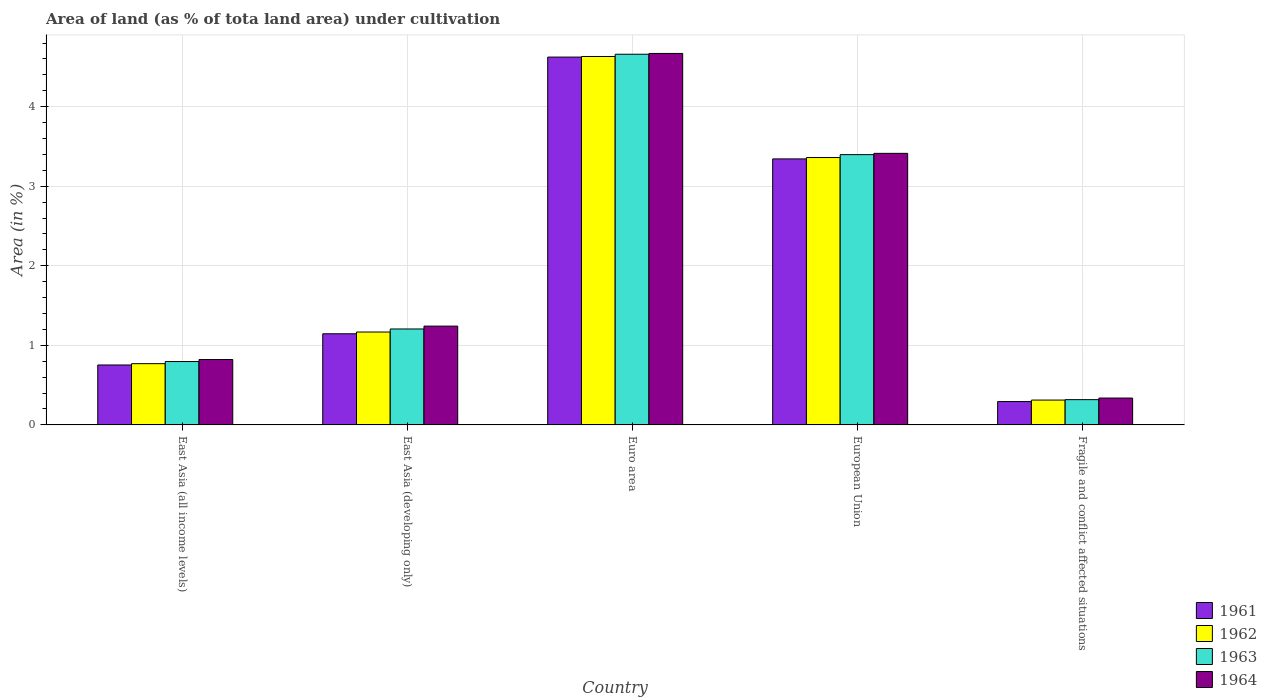How many groups of bars are there?
Your answer should be compact. 5. Are the number of bars per tick equal to the number of legend labels?
Your answer should be very brief. Yes. Are the number of bars on each tick of the X-axis equal?
Ensure brevity in your answer.  Yes. How many bars are there on the 2nd tick from the right?
Your answer should be compact. 4. What is the label of the 2nd group of bars from the left?
Your answer should be very brief. East Asia (developing only). What is the percentage of land under cultivation in 1961 in Euro area?
Provide a succinct answer. 4.62. Across all countries, what is the maximum percentage of land under cultivation in 1963?
Your answer should be compact. 4.66. Across all countries, what is the minimum percentage of land under cultivation in 1962?
Ensure brevity in your answer.  0.31. In which country was the percentage of land under cultivation in 1964 maximum?
Your answer should be very brief. Euro area. In which country was the percentage of land under cultivation in 1961 minimum?
Provide a succinct answer. Fragile and conflict affected situations. What is the total percentage of land under cultivation in 1962 in the graph?
Your answer should be compact. 10.24. What is the difference between the percentage of land under cultivation in 1961 in East Asia (developing only) and that in Fragile and conflict affected situations?
Your answer should be very brief. 0.85. What is the difference between the percentage of land under cultivation in 1963 in European Union and the percentage of land under cultivation in 1964 in East Asia (developing only)?
Give a very brief answer. 2.16. What is the average percentage of land under cultivation in 1962 per country?
Keep it short and to the point. 2.05. What is the difference between the percentage of land under cultivation of/in 1961 and percentage of land under cultivation of/in 1963 in Fragile and conflict affected situations?
Make the answer very short. -0.02. In how many countries, is the percentage of land under cultivation in 1964 greater than 1.2 %?
Your response must be concise. 3. What is the ratio of the percentage of land under cultivation in 1962 in East Asia (all income levels) to that in Fragile and conflict affected situations?
Your response must be concise. 2.47. Is the percentage of land under cultivation in 1964 in East Asia (all income levels) less than that in Fragile and conflict affected situations?
Your answer should be very brief. No. Is the difference between the percentage of land under cultivation in 1961 in European Union and Fragile and conflict affected situations greater than the difference between the percentage of land under cultivation in 1963 in European Union and Fragile and conflict affected situations?
Your answer should be very brief. No. What is the difference between the highest and the second highest percentage of land under cultivation in 1961?
Your response must be concise. -2.2. What is the difference between the highest and the lowest percentage of land under cultivation in 1963?
Make the answer very short. 4.34. What does the 2nd bar from the left in European Union represents?
Offer a terse response. 1962. What does the 2nd bar from the right in East Asia (developing only) represents?
Your answer should be very brief. 1963. How many bars are there?
Offer a very short reply. 20. Are all the bars in the graph horizontal?
Keep it short and to the point. No. What is the difference between two consecutive major ticks on the Y-axis?
Offer a terse response. 1. Are the values on the major ticks of Y-axis written in scientific E-notation?
Offer a terse response. No. Does the graph contain any zero values?
Your answer should be compact. No. Does the graph contain grids?
Keep it short and to the point. Yes. Where does the legend appear in the graph?
Provide a short and direct response. Bottom right. What is the title of the graph?
Provide a short and direct response. Area of land (as % of tota land area) under cultivation. Does "2014" appear as one of the legend labels in the graph?
Provide a short and direct response. No. What is the label or title of the X-axis?
Keep it short and to the point. Country. What is the label or title of the Y-axis?
Your answer should be very brief. Area (in %). What is the Area (in %) in 1961 in East Asia (all income levels)?
Offer a very short reply. 0.75. What is the Area (in %) in 1962 in East Asia (all income levels)?
Your response must be concise. 0.77. What is the Area (in %) in 1963 in East Asia (all income levels)?
Keep it short and to the point. 0.8. What is the Area (in %) of 1964 in East Asia (all income levels)?
Ensure brevity in your answer.  0.82. What is the Area (in %) of 1961 in East Asia (developing only)?
Make the answer very short. 1.15. What is the Area (in %) in 1962 in East Asia (developing only)?
Ensure brevity in your answer.  1.17. What is the Area (in %) of 1963 in East Asia (developing only)?
Your response must be concise. 1.21. What is the Area (in %) of 1964 in East Asia (developing only)?
Offer a very short reply. 1.24. What is the Area (in %) in 1961 in Euro area?
Your response must be concise. 4.62. What is the Area (in %) of 1962 in Euro area?
Provide a short and direct response. 4.63. What is the Area (in %) in 1963 in Euro area?
Your response must be concise. 4.66. What is the Area (in %) of 1964 in Euro area?
Offer a very short reply. 4.67. What is the Area (in %) of 1961 in European Union?
Ensure brevity in your answer.  3.34. What is the Area (in %) of 1962 in European Union?
Keep it short and to the point. 3.36. What is the Area (in %) in 1963 in European Union?
Ensure brevity in your answer.  3.4. What is the Area (in %) in 1964 in European Union?
Make the answer very short. 3.41. What is the Area (in %) of 1961 in Fragile and conflict affected situations?
Ensure brevity in your answer.  0.29. What is the Area (in %) in 1962 in Fragile and conflict affected situations?
Keep it short and to the point. 0.31. What is the Area (in %) in 1963 in Fragile and conflict affected situations?
Ensure brevity in your answer.  0.32. What is the Area (in %) in 1964 in Fragile and conflict affected situations?
Ensure brevity in your answer.  0.34. Across all countries, what is the maximum Area (in %) in 1961?
Make the answer very short. 4.62. Across all countries, what is the maximum Area (in %) of 1962?
Your response must be concise. 4.63. Across all countries, what is the maximum Area (in %) of 1963?
Ensure brevity in your answer.  4.66. Across all countries, what is the maximum Area (in %) of 1964?
Offer a terse response. 4.67. Across all countries, what is the minimum Area (in %) in 1961?
Give a very brief answer. 0.29. Across all countries, what is the minimum Area (in %) in 1962?
Your answer should be very brief. 0.31. Across all countries, what is the minimum Area (in %) in 1963?
Provide a succinct answer. 0.32. Across all countries, what is the minimum Area (in %) of 1964?
Your answer should be compact. 0.34. What is the total Area (in %) in 1961 in the graph?
Your response must be concise. 10.16. What is the total Area (in %) of 1962 in the graph?
Provide a succinct answer. 10.24. What is the total Area (in %) in 1963 in the graph?
Provide a succinct answer. 10.38. What is the total Area (in %) in 1964 in the graph?
Give a very brief answer. 10.48. What is the difference between the Area (in %) of 1961 in East Asia (all income levels) and that in East Asia (developing only)?
Your answer should be very brief. -0.39. What is the difference between the Area (in %) of 1962 in East Asia (all income levels) and that in East Asia (developing only)?
Your answer should be compact. -0.4. What is the difference between the Area (in %) of 1963 in East Asia (all income levels) and that in East Asia (developing only)?
Your answer should be very brief. -0.41. What is the difference between the Area (in %) of 1964 in East Asia (all income levels) and that in East Asia (developing only)?
Your answer should be compact. -0.42. What is the difference between the Area (in %) of 1961 in East Asia (all income levels) and that in Euro area?
Offer a terse response. -3.87. What is the difference between the Area (in %) of 1962 in East Asia (all income levels) and that in Euro area?
Provide a short and direct response. -3.86. What is the difference between the Area (in %) in 1963 in East Asia (all income levels) and that in Euro area?
Keep it short and to the point. -3.86. What is the difference between the Area (in %) in 1964 in East Asia (all income levels) and that in Euro area?
Make the answer very short. -3.85. What is the difference between the Area (in %) in 1961 in East Asia (all income levels) and that in European Union?
Give a very brief answer. -2.59. What is the difference between the Area (in %) of 1962 in East Asia (all income levels) and that in European Union?
Your response must be concise. -2.59. What is the difference between the Area (in %) of 1963 in East Asia (all income levels) and that in European Union?
Provide a succinct answer. -2.6. What is the difference between the Area (in %) in 1964 in East Asia (all income levels) and that in European Union?
Give a very brief answer. -2.59. What is the difference between the Area (in %) in 1961 in East Asia (all income levels) and that in Fragile and conflict affected situations?
Offer a very short reply. 0.46. What is the difference between the Area (in %) in 1962 in East Asia (all income levels) and that in Fragile and conflict affected situations?
Your answer should be compact. 0.46. What is the difference between the Area (in %) of 1963 in East Asia (all income levels) and that in Fragile and conflict affected situations?
Make the answer very short. 0.48. What is the difference between the Area (in %) of 1964 in East Asia (all income levels) and that in Fragile and conflict affected situations?
Offer a very short reply. 0.48. What is the difference between the Area (in %) in 1961 in East Asia (developing only) and that in Euro area?
Your response must be concise. -3.48. What is the difference between the Area (in %) of 1962 in East Asia (developing only) and that in Euro area?
Ensure brevity in your answer.  -3.46. What is the difference between the Area (in %) of 1963 in East Asia (developing only) and that in Euro area?
Keep it short and to the point. -3.45. What is the difference between the Area (in %) in 1964 in East Asia (developing only) and that in Euro area?
Offer a very short reply. -3.43. What is the difference between the Area (in %) in 1961 in East Asia (developing only) and that in European Union?
Ensure brevity in your answer.  -2.2. What is the difference between the Area (in %) of 1962 in East Asia (developing only) and that in European Union?
Ensure brevity in your answer.  -2.19. What is the difference between the Area (in %) in 1963 in East Asia (developing only) and that in European Union?
Your answer should be very brief. -2.19. What is the difference between the Area (in %) in 1964 in East Asia (developing only) and that in European Union?
Your answer should be compact. -2.17. What is the difference between the Area (in %) of 1961 in East Asia (developing only) and that in Fragile and conflict affected situations?
Your response must be concise. 0.85. What is the difference between the Area (in %) of 1962 in East Asia (developing only) and that in Fragile and conflict affected situations?
Your response must be concise. 0.86. What is the difference between the Area (in %) in 1963 in East Asia (developing only) and that in Fragile and conflict affected situations?
Keep it short and to the point. 0.89. What is the difference between the Area (in %) in 1964 in East Asia (developing only) and that in Fragile and conflict affected situations?
Provide a succinct answer. 0.9. What is the difference between the Area (in %) in 1961 in Euro area and that in European Union?
Your answer should be compact. 1.28. What is the difference between the Area (in %) in 1962 in Euro area and that in European Union?
Make the answer very short. 1.27. What is the difference between the Area (in %) of 1963 in Euro area and that in European Union?
Offer a terse response. 1.26. What is the difference between the Area (in %) in 1964 in Euro area and that in European Union?
Ensure brevity in your answer.  1.26. What is the difference between the Area (in %) of 1961 in Euro area and that in Fragile and conflict affected situations?
Make the answer very short. 4.33. What is the difference between the Area (in %) of 1962 in Euro area and that in Fragile and conflict affected situations?
Make the answer very short. 4.32. What is the difference between the Area (in %) in 1963 in Euro area and that in Fragile and conflict affected situations?
Ensure brevity in your answer.  4.34. What is the difference between the Area (in %) in 1964 in Euro area and that in Fragile and conflict affected situations?
Give a very brief answer. 4.33. What is the difference between the Area (in %) in 1961 in European Union and that in Fragile and conflict affected situations?
Offer a terse response. 3.05. What is the difference between the Area (in %) in 1962 in European Union and that in Fragile and conflict affected situations?
Ensure brevity in your answer.  3.05. What is the difference between the Area (in %) in 1963 in European Union and that in Fragile and conflict affected situations?
Make the answer very short. 3.08. What is the difference between the Area (in %) of 1964 in European Union and that in Fragile and conflict affected situations?
Your answer should be compact. 3.08. What is the difference between the Area (in %) of 1961 in East Asia (all income levels) and the Area (in %) of 1962 in East Asia (developing only)?
Your answer should be compact. -0.41. What is the difference between the Area (in %) of 1961 in East Asia (all income levels) and the Area (in %) of 1963 in East Asia (developing only)?
Offer a terse response. -0.45. What is the difference between the Area (in %) in 1961 in East Asia (all income levels) and the Area (in %) in 1964 in East Asia (developing only)?
Provide a short and direct response. -0.49. What is the difference between the Area (in %) of 1962 in East Asia (all income levels) and the Area (in %) of 1963 in East Asia (developing only)?
Keep it short and to the point. -0.44. What is the difference between the Area (in %) of 1962 in East Asia (all income levels) and the Area (in %) of 1964 in East Asia (developing only)?
Keep it short and to the point. -0.47. What is the difference between the Area (in %) in 1963 in East Asia (all income levels) and the Area (in %) in 1964 in East Asia (developing only)?
Your response must be concise. -0.45. What is the difference between the Area (in %) of 1961 in East Asia (all income levels) and the Area (in %) of 1962 in Euro area?
Ensure brevity in your answer.  -3.88. What is the difference between the Area (in %) in 1961 in East Asia (all income levels) and the Area (in %) in 1963 in Euro area?
Provide a succinct answer. -3.91. What is the difference between the Area (in %) of 1961 in East Asia (all income levels) and the Area (in %) of 1964 in Euro area?
Provide a succinct answer. -3.92. What is the difference between the Area (in %) in 1962 in East Asia (all income levels) and the Area (in %) in 1963 in Euro area?
Ensure brevity in your answer.  -3.89. What is the difference between the Area (in %) in 1962 in East Asia (all income levels) and the Area (in %) in 1964 in Euro area?
Offer a very short reply. -3.9. What is the difference between the Area (in %) of 1963 in East Asia (all income levels) and the Area (in %) of 1964 in Euro area?
Provide a short and direct response. -3.87. What is the difference between the Area (in %) of 1961 in East Asia (all income levels) and the Area (in %) of 1962 in European Union?
Make the answer very short. -2.61. What is the difference between the Area (in %) in 1961 in East Asia (all income levels) and the Area (in %) in 1963 in European Union?
Your answer should be very brief. -2.64. What is the difference between the Area (in %) in 1961 in East Asia (all income levels) and the Area (in %) in 1964 in European Union?
Ensure brevity in your answer.  -2.66. What is the difference between the Area (in %) of 1962 in East Asia (all income levels) and the Area (in %) of 1963 in European Union?
Keep it short and to the point. -2.63. What is the difference between the Area (in %) in 1962 in East Asia (all income levels) and the Area (in %) in 1964 in European Union?
Keep it short and to the point. -2.64. What is the difference between the Area (in %) in 1963 in East Asia (all income levels) and the Area (in %) in 1964 in European Union?
Offer a terse response. -2.62. What is the difference between the Area (in %) of 1961 in East Asia (all income levels) and the Area (in %) of 1962 in Fragile and conflict affected situations?
Your answer should be very brief. 0.44. What is the difference between the Area (in %) in 1961 in East Asia (all income levels) and the Area (in %) in 1963 in Fragile and conflict affected situations?
Provide a succinct answer. 0.44. What is the difference between the Area (in %) of 1961 in East Asia (all income levels) and the Area (in %) of 1964 in Fragile and conflict affected situations?
Your answer should be compact. 0.42. What is the difference between the Area (in %) of 1962 in East Asia (all income levels) and the Area (in %) of 1963 in Fragile and conflict affected situations?
Offer a very short reply. 0.45. What is the difference between the Area (in %) of 1962 in East Asia (all income levels) and the Area (in %) of 1964 in Fragile and conflict affected situations?
Your answer should be compact. 0.43. What is the difference between the Area (in %) of 1963 in East Asia (all income levels) and the Area (in %) of 1964 in Fragile and conflict affected situations?
Provide a succinct answer. 0.46. What is the difference between the Area (in %) of 1961 in East Asia (developing only) and the Area (in %) of 1962 in Euro area?
Offer a terse response. -3.49. What is the difference between the Area (in %) in 1961 in East Asia (developing only) and the Area (in %) in 1963 in Euro area?
Provide a succinct answer. -3.51. What is the difference between the Area (in %) in 1961 in East Asia (developing only) and the Area (in %) in 1964 in Euro area?
Provide a succinct answer. -3.52. What is the difference between the Area (in %) in 1962 in East Asia (developing only) and the Area (in %) in 1963 in Euro area?
Your answer should be compact. -3.49. What is the difference between the Area (in %) in 1962 in East Asia (developing only) and the Area (in %) in 1964 in Euro area?
Keep it short and to the point. -3.5. What is the difference between the Area (in %) of 1963 in East Asia (developing only) and the Area (in %) of 1964 in Euro area?
Provide a short and direct response. -3.46. What is the difference between the Area (in %) in 1961 in East Asia (developing only) and the Area (in %) in 1962 in European Union?
Keep it short and to the point. -2.22. What is the difference between the Area (in %) of 1961 in East Asia (developing only) and the Area (in %) of 1963 in European Union?
Provide a short and direct response. -2.25. What is the difference between the Area (in %) in 1961 in East Asia (developing only) and the Area (in %) in 1964 in European Union?
Your response must be concise. -2.27. What is the difference between the Area (in %) in 1962 in East Asia (developing only) and the Area (in %) in 1963 in European Union?
Provide a succinct answer. -2.23. What is the difference between the Area (in %) in 1962 in East Asia (developing only) and the Area (in %) in 1964 in European Union?
Offer a very short reply. -2.25. What is the difference between the Area (in %) in 1963 in East Asia (developing only) and the Area (in %) in 1964 in European Union?
Give a very brief answer. -2.21. What is the difference between the Area (in %) of 1961 in East Asia (developing only) and the Area (in %) of 1962 in Fragile and conflict affected situations?
Offer a very short reply. 0.83. What is the difference between the Area (in %) of 1961 in East Asia (developing only) and the Area (in %) of 1963 in Fragile and conflict affected situations?
Your answer should be compact. 0.83. What is the difference between the Area (in %) in 1961 in East Asia (developing only) and the Area (in %) in 1964 in Fragile and conflict affected situations?
Your answer should be compact. 0.81. What is the difference between the Area (in %) in 1962 in East Asia (developing only) and the Area (in %) in 1963 in Fragile and conflict affected situations?
Ensure brevity in your answer.  0.85. What is the difference between the Area (in %) in 1962 in East Asia (developing only) and the Area (in %) in 1964 in Fragile and conflict affected situations?
Give a very brief answer. 0.83. What is the difference between the Area (in %) in 1963 in East Asia (developing only) and the Area (in %) in 1964 in Fragile and conflict affected situations?
Keep it short and to the point. 0.87. What is the difference between the Area (in %) in 1961 in Euro area and the Area (in %) in 1962 in European Union?
Your answer should be very brief. 1.26. What is the difference between the Area (in %) in 1961 in Euro area and the Area (in %) in 1963 in European Union?
Offer a terse response. 1.23. What is the difference between the Area (in %) of 1961 in Euro area and the Area (in %) of 1964 in European Union?
Keep it short and to the point. 1.21. What is the difference between the Area (in %) of 1962 in Euro area and the Area (in %) of 1963 in European Union?
Offer a very short reply. 1.23. What is the difference between the Area (in %) in 1962 in Euro area and the Area (in %) in 1964 in European Union?
Your response must be concise. 1.22. What is the difference between the Area (in %) in 1963 in Euro area and the Area (in %) in 1964 in European Union?
Offer a very short reply. 1.25. What is the difference between the Area (in %) of 1961 in Euro area and the Area (in %) of 1962 in Fragile and conflict affected situations?
Offer a terse response. 4.31. What is the difference between the Area (in %) of 1961 in Euro area and the Area (in %) of 1963 in Fragile and conflict affected situations?
Offer a very short reply. 4.31. What is the difference between the Area (in %) in 1961 in Euro area and the Area (in %) in 1964 in Fragile and conflict affected situations?
Make the answer very short. 4.29. What is the difference between the Area (in %) in 1962 in Euro area and the Area (in %) in 1963 in Fragile and conflict affected situations?
Offer a terse response. 4.31. What is the difference between the Area (in %) of 1962 in Euro area and the Area (in %) of 1964 in Fragile and conflict affected situations?
Give a very brief answer. 4.29. What is the difference between the Area (in %) of 1963 in Euro area and the Area (in %) of 1964 in Fragile and conflict affected situations?
Ensure brevity in your answer.  4.32. What is the difference between the Area (in %) of 1961 in European Union and the Area (in %) of 1962 in Fragile and conflict affected situations?
Keep it short and to the point. 3.03. What is the difference between the Area (in %) of 1961 in European Union and the Area (in %) of 1963 in Fragile and conflict affected situations?
Make the answer very short. 3.03. What is the difference between the Area (in %) in 1961 in European Union and the Area (in %) in 1964 in Fragile and conflict affected situations?
Make the answer very short. 3.01. What is the difference between the Area (in %) of 1962 in European Union and the Area (in %) of 1963 in Fragile and conflict affected situations?
Keep it short and to the point. 3.04. What is the difference between the Area (in %) of 1962 in European Union and the Area (in %) of 1964 in Fragile and conflict affected situations?
Offer a terse response. 3.02. What is the difference between the Area (in %) of 1963 in European Union and the Area (in %) of 1964 in Fragile and conflict affected situations?
Provide a succinct answer. 3.06. What is the average Area (in %) of 1961 per country?
Your response must be concise. 2.03. What is the average Area (in %) of 1962 per country?
Offer a terse response. 2.05. What is the average Area (in %) in 1963 per country?
Your answer should be compact. 2.08. What is the average Area (in %) of 1964 per country?
Your response must be concise. 2.1. What is the difference between the Area (in %) in 1961 and Area (in %) in 1962 in East Asia (all income levels)?
Offer a terse response. -0.02. What is the difference between the Area (in %) of 1961 and Area (in %) of 1963 in East Asia (all income levels)?
Offer a very short reply. -0.04. What is the difference between the Area (in %) in 1961 and Area (in %) in 1964 in East Asia (all income levels)?
Make the answer very short. -0.07. What is the difference between the Area (in %) in 1962 and Area (in %) in 1963 in East Asia (all income levels)?
Your answer should be compact. -0.03. What is the difference between the Area (in %) of 1962 and Area (in %) of 1964 in East Asia (all income levels)?
Keep it short and to the point. -0.05. What is the difference between the Area (in %) of 1963 and Area (in %) of 1964 in East Asia (all income levels)?
Offer a terse response. -0.03. What is the difference between the Area (in %) of 1961 and Area (in %) of 1962 in East Asia (developing only)?
Keep it short and to the point. -0.02. What is the difference between the Area (in %) of 1961 and Area (in %) of 1963 in East Asia (developing only)?
Keep it short and to the point. -0.06. What is the difference between the Area (in %) of 1961 and Area (in %) of 1964 in East Asia (developing only)?
Your answer should be very brief. -0.1. What is the difference between the Area (in %) in 1962 and Area (in %) in 1963 in East Asia (developing only)?
Your response must be concise. -0.04. What is the difference between the Area (in %) of 1962 and Area (in %) of 1964 in East Asia (developing only)?
Provide a succinct answer. -0.07. What is the difference between the Area (in %) in 1963 and Area (in %) in 1964 in East Asia (developing only)?
Offer a very short reply. -0.04. What is the difference between the Area (in %) of 1961 and Area (in %) of 1962 in Euro area?
Give a very brief answer. -0.01. What is the difference between the Area (in %) of 1961 and Area (in %) of 1963 in Euro area?
Offer a very short reply. -0.04. What is the difference between the Area (in %) in 1961 and Area (in %) in 1964 in Euro area?
Offer a very short reply. -0.05. What is the difference between the Area (in %) of 1962 and Area (in %) of 1963 in Euro area?
Offer a very short reply. -0.03. What is the difference between the Area (in %) in 1962 and Area (in %) in 1964 in Euro area?
Your response must be concise. -0.04. What is the difference between the Area (in %) of 1963 and Area (in %) of 1964 in Euro area?
Give a very brief answer. -0.01. What is the difference between the Area (in %) of 1961 and Area (in %) of 1962 in European Union?
Your response must be concise. -0.02. What is the difference between the Area (in %) in 1961 and Area (in %) in 1963 in European Union?
Keep it short and to the point. -0.05. What is the difference between the Area (in %) of 1961 and Area (in %) of 1964 in European Union?
Your answer should be very brief. -0.07. What is the difference between the Area (in %) of 1962 and Area (in %) of 1963 in European Union?
Your answer should be compact. -0.04. What is the difference between the Area (in %) in 1962 and Area (in %) in 1964 in European Union?
Your answer should be compact. -0.05. What is the difference between the Area (in %) in 1963 and Area (in %) in 1964 in European Union?
Make the answer very short. -0.02. What is the difference between the Area (in %) in 1961 and Area (in %) in 1962 in Fragile and conflict affected situations?
Offer a terse response. -0.02. What is the difference between the Area (in %) in 1961 and Area (in %) in 1963 in Fragile and conflict affected situations?
Your response must be concise. -0.02. What is the difference between the Area (in %) of 1961 and Area (in %) of 1964 in Fragile and conflict affected situations?
Provide a succinct answer. -0.04. What is the difference between the Area (in %) in 1962 and Area (in %) in 1963 in Fragile and conflict affected situations?
Offer a very short reply. -0.01. What is the difference between the Area (in %) in 1962 and Area (in %) in 1964 in Fragile and conflict affected situations?
Offer a very short reply. -0.03. What is the difference between the Area (in %) in 1963 and Area (in %) in 1964 in Fragile and conflict affected situations?
Keep it short and to the point. -0.02. What is the ratio of the Area (in %) of 1961 in East Asia (all income levels) to that in East Asia (developing only)?
Offer a terse response. 0.66. What is the ratio of the Area (in %) of 1962 in East Asia (all income levels) to that in East Asia (developing only)?
Provide a succinct answer. 0.66. What is the ratio of the Area (in %) in 1963 in East Asia (all income levels) to that in East Asia (developing only)?
Provide a short and direct response. 0.66. What is the ratio of the Area (in %) of 1964 in East Asia (all income levels) to that in East Asia (developing only)?
Ensure brevity in your answer.  0.66. What is the ratio of the Area (in %) in 1961 in East Asia (all income levels) to that in Euro area?
Offer a terse response. 0.16. What is the ratio of the Area (in %) in 1962 in East Asia (all income levels) to that in Euro area?
Provide a short and direct response. 0.17. What is the ratio of the Area (in %) in 1963 in East Asia (all income levels) to that in Euro area?
Make the answer very short. 0.17. What is the ratio of the Area (in %) in 1964 in East Asia (all income levels) to that in Euro area?
Keep it short and to the point. 0.18. What is the ratio of the Area (in %) in 1961 in East Asia (all income levels) to that in European Union?
Ensure brevity in your answer.  0.23. What is the ratio of the Area (in %) in 1962 in East Asia (all income levels) to that in European Union?
Offer a terse response. 0.23. What is the ratio of the Area (in %) of 1963 in East Asia (all income levels) to that in European Union?
Give a very brief answer. 0.23. What is the ratio of the Area (in %) of 1964 in East Asia (all income levels) to that in European Union?
Keep it short and to the point. 0.24. What is the ratio of the Area (in %) in 1961 in East Asia (all income levels) to that in Fragile and conflict affected situations?
Offer a very short reply. 2.57. What is the ratio of the Area (in %) of 1962 in East Asia (all income levels) to that in Fragile and conflict affected situations?
Ensure brevity in your answer.  2.47. What is the ratio of the Area (in %) in 1963 in East Asia (all income levels) to that in Fragile and conflict affected situations?
Offer a very short reply. 2.51. What is the ratio of the Area (in %) in 1964 in East Asia (all income levels) to that in Fragile and conflict affected situations?
Offer a terse response. 2.44. What is the ratio of the Area (in %) in 1961 in East Asia (developing only) to that in Euro area?
Provide a short and direct response. 0.25. What is the ratio of the Area (in %) of 1962 in East Asia (developing only) to that in Euro area?
Ensure brevity in your answer.  0.25. What is the ratio of the Area (in %) in 1963 in East Asia (developing only) to that in Euro area?
Keep it short and to the point. 0.26. What is the ratio of the Area (in %) of 1964 in East Asia (developing only) to that in Euro area?
Keep it short and to the point. 0.27. What is the ratio of the Area (in %) of 1961 in East Asia (developing only) to that in European Union?
Your answer should be compact. 0.34. What is the ratio of the Area (in %) in 1962 in East Asia (developing only) to that in European Union?
Keep it short and to the point. 0.35. What is the ratio of the Area (in %) of 1963 in East Asia (developing only) to that in European Union?
Offer a very short reply. 0.35. What is the ratio of the Area (in %) in 1964 in East Asia (developing only) to that in European Union?
Offer a terse response. 0.36. What is the ratio of the Area (in %) of 1961 in East Asia (developing only) to that in Fragile and conflict affected situations?
Make the answer very short. 3.9. What is the ratio of the Area (in %) of 1962 in East Asia (developing only) to that in Fragile and conflict affected situations?
Your response must be concise. 3.74. What is the ratio of the Area (in %) of 1963 in East Asia (developing only) to that in Fragile and conflict affected situations?
Give a very brief answer. 3.8. What is the ratio of the Area (in %) in 1964 in East Asia (developing only) to that in Fragile and conflict affected situations?
Your answer should be compact. 3.68. What is the ratio of the Area (in %) of 1961 in Euro area to that in European Union?
Your answer should be compact. 1.38. What is the ratio of the Area (in %) in 1962 in Euro area to that in European Union?
Provide a succinct answer. 1.38. What is the ratio of the Area (in %) in 1963 in Euro area to that in European Union?
Ensure brevity in your answer.  1.37. What is the ratio of the Area (in %) in 1964 in Euro area to that in European Union?
Ensure brevity in your answer.  1.37. What is the ratio of the Area (in %) in 1961 in Euro area to that in Fragile and conflict affected situations?
Your answer should be very brief. 15.76. What is the ratio of the Area (in %) in 1962 in Euro area to that in Fragile and conflict affected situations?
Your response must be concise. 14.83. What is the ratio of the Area (in %) in 1963 in Euro area to that in Fragile and conflict affected situations?
Your response must be concise. 14.67. What is the ratio of the Area (in %) of 1964 in Euro area to that in Fragile and conflict affected situations?
Your answer should be compact. 13.83. What is the ratio of the Area (in %) in 1961 in European Union to that in Fragile and conflict affected situations?
Keep it short and to the point. 11.39. What is the ratio of the Area (in %) in 1962 in European Union to that in Fragile and conflict affected situations?
Offer a very short reply. 10.76. What is the ratio of the Area (in %) in 1963 in European Union to that in Fragile and conflict affected situations?
Ensure brevity in your answer.  10.7. What is the ratio of the Area (in %) of 1964 in European Union to that in Fragile and conflict affected situations?
Keep it short and to the point. 10.11. What is the difference between the highest and the second highest Area (in %) in 1961?
Offer a very short reply. 1.28. What is the difference between the highest and the second highest Area (in %) of 1962?
Offer a very short reply. 1.27. What is the difference between the highest and the second highest Area (in %) of 1963?
Your response must be concise. 1.26. What is the difference between the highest and the second highest Area (in %) of 1964?
Give a very brief answer. 1.26. What is the difference between the highest and the lowest Area (in %) in 1961?
Make the answer very short. 4.33. What is the difference between the highest and the lowest Area (in %) in 1962?
Your answer should be very brief. 4.32. What is the difference between the highest and the lowest Area (in %) in 1963?
Your response must be concise. 4.34. What is the difference between the highest and the lowest Area (in %) in 1964?
Your answer should be very brief. 4.33. 